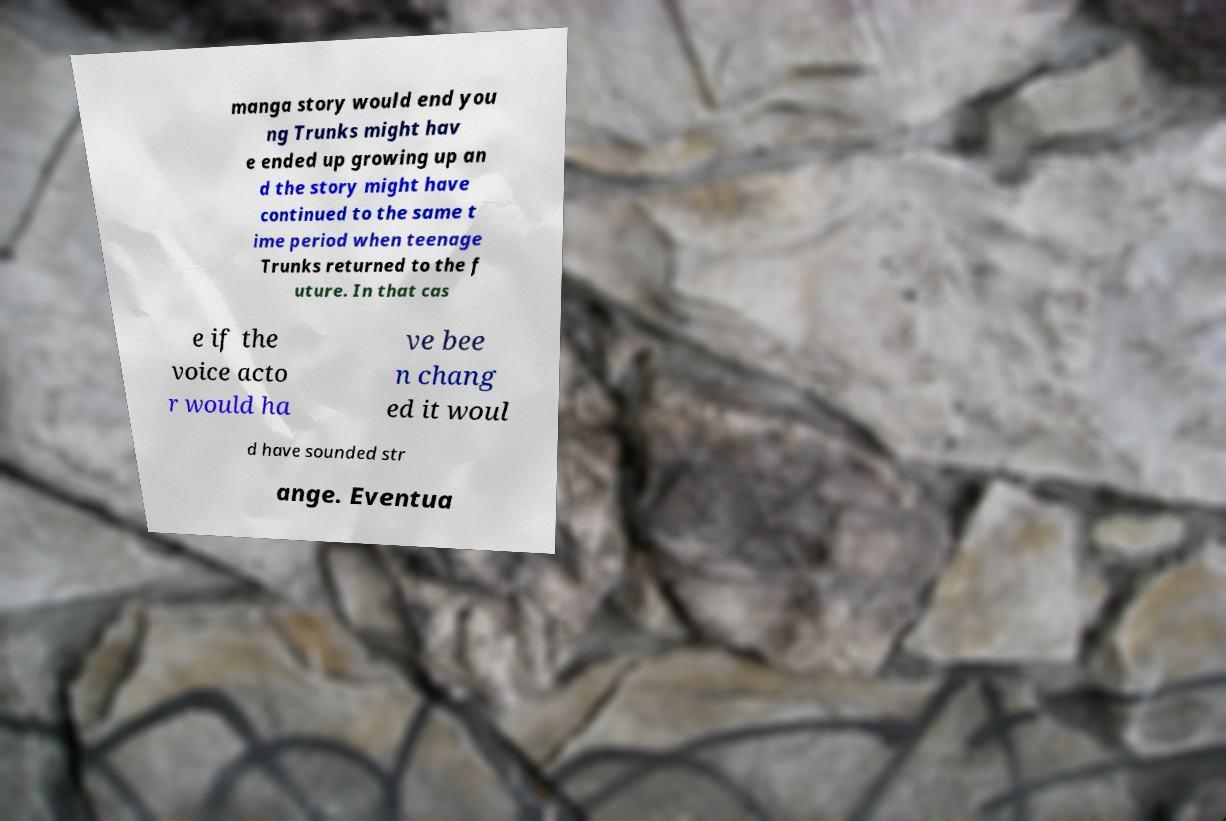Could you extract and type out the text from this image? manga story would end you ng Trunks might hav e ended up growing up an d the story might have continued to the same t ime period when teenage Trunks returned to the f uture. In that cas e if the voice acto r would ha ve bee n chang ed it woul d have sounded str ange. Eventua 